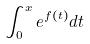<formula> <loc_0><loc_0><loc_500><loc_500>\int _ { 0 } ^ { x } e ^ { f ( t ) } d t</formula> 